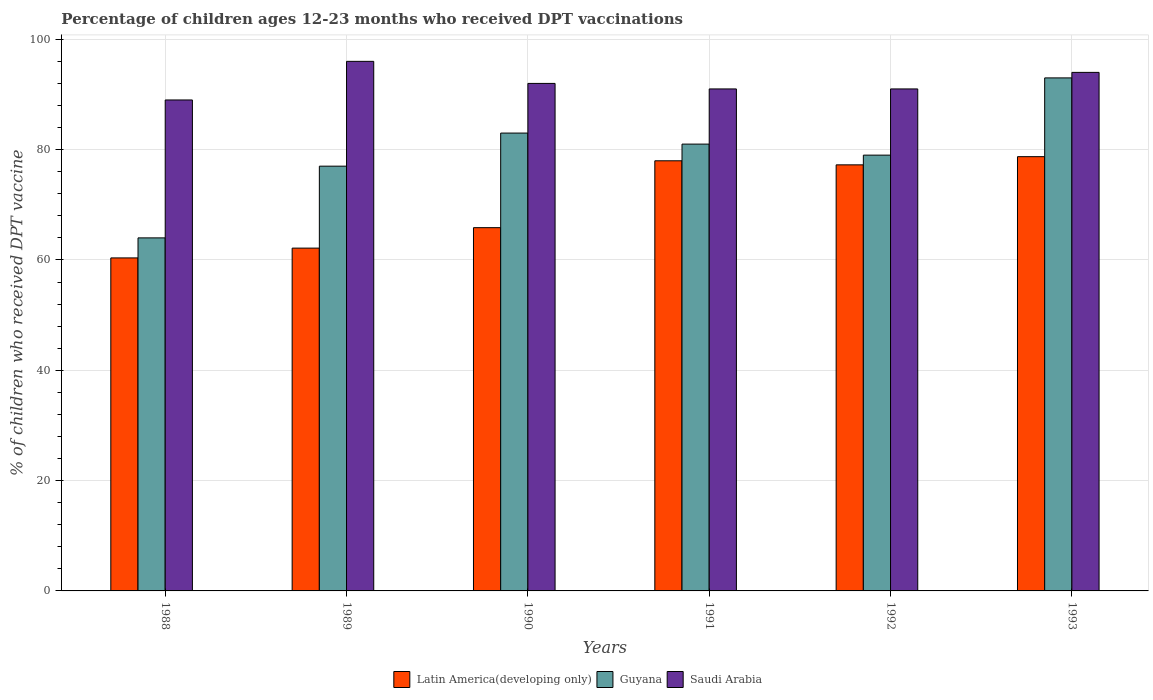How many groups of bars are there?
Keep it short and to the point. 6. Are the number of bars per tick equal to the number of legend labels?
Your answer should be very brief. Yes. What is the percentage of children who received DPT vaccination in Guyana in 1992?
Make the answer very short. 79. Across all years, what is the maximum percentage of children who received DPT vaccination in Guyana?
Your response must be concise. 93. Across all years, what is the minimum percentage of children who received DPT vaccination in Guyana?
Provide a short and direct response. 64. In which year was the percentage of children who received DPT vaccination in Saudi Arabia maximum?
Keep it short and to the point. 1989. What is the total percentage of children who received DPT vaccination in Guyana in the graph?
Make the answer very short. 477. What is the difference between the percentage of children who received DPT vaccination in Guyana in 1990 and that in 1991?
Give a very brief answer. 2. What is the difference between the percentage of children who received DPT vaccination in Guyana in 1993 and the percentage of children who received DPT vaccination in Saudi Arabia in 1989?
Ensure brevity in your answer.  -3. What is the average percentage of children who received DPT vaccination in Latin America(developing only) per year?
Provide a short and direct response. 70.38. In the year 1991, what is the difference between the percentage of children who received DPT vaccination in Guyana and percentage of children who received DPT vaccination in Saudi Arabia?
Offer a very short reply. -10. What is the ratio of the percentage of children who received DPT vaccination in Saudi Arabia in 1990 to that in 1991?
Your answer should be compact. 1.01. Is the percentage of children who received DPT vaccination in Latin America(developing only) in 1988 less than that in 1993?
Keep it short and to the point. Yes. What is the difference between the highest and the second highest percentage of children who received DPT vaccination in Latin America(developing only)?
Your response must be concise. 0.75. What is the difference between the highest and the lowest percentage of children who received DPT vaccination in Latin America(developing only)?
Offer a very short reply. 18.35. In how many years, is the percentage of children who received DPT vaccination in Saudi Arabia greater than the average percentage of children who received DPT vaccination in Saudi Arabia taken over all years?
Offer a very short reply. 2. Is the sum of the percentage of children who received DPT vaccination in Latin America(developing only) in 1991 and 1992 greater than the maximum percentage of children who received DPT vaccination in Guyana across all years?
Offer a very short reply. Yes. What does the 1st bar from the left in 1991 represents?
Your response must be concise. Latin America(developing only). What does the 1st bar from the right in 1992 represents?
Give a very brief answer. Saudi Arabia. Is it the case that in every year, the sum of the percentage of children who received DPT vaccination in Latin America(developing only) and percentage of children who received DPT vaccination in Saudi Arabia is greater than the percentage of children who received DPT vaccination in Guyana?
Your answer should be compact. Yes. How many bars are there?
Provide a short and direct response. 18. Where does the legend appear in the graph?
Ensure brevity in your answer.  Bottom center. What is the title of the graph?
Your response must be concise. Percentage of children ages 12-23 months who received DPT vaccinations. Does "Curacao" appear as one of the legend labels in the graph?
Offer a terse response. No. What is the label or title of the X-axis?
Offer a very short reply. Years. What is the label or title of the Y-axis?
Make the answer very short. % of children who received DPT vaccine. What is the % of children who received DPT vaccine in Latin America(developing only) in 1988?
Your answer should be very brief. 60.37. What is the % of children who received DPT vaccine of Saudi Arabia in 1988?
Provide a succinct answer. 89. What is the % of children who received DPT vaccine of Latin America(developing only) in 1989?
Make the answer very short. 62.14. What is the % of children who received DPT vaccine in Saudi Arabia in 1989?
Make the answer very short. 96. What is the % of children who received DPT vaccine of Latin America(developing only) in 1990?
Your answer should be compact. 65.85. What is the % of children who received DPT vaccine in Saudi Arabia in 1990?
Give a very brief answer. 92. What is the % of children who received DPT vaccine in Latin America(developing only) in 1991?
Offer a terse response. 77.97. What is the % of children who received DPT vaccine of Guyana in 1991?
Make the answer very short. 81. What is the % of children who received DPT vaccine in Saudi Arabia in 1991?
Your answer should be compact. 91. What is the % of children who received DPT vaccine in Latin America(developing only) in 1992?
Your answer should be very brief. 77.24. What is the % of children who received DPT vaccine of Guyana in 1992?
Offer a very short reply. 79. What is the % of children who received DPT vaccine of Saudi Arabia in 1992?
Offer a terse response. 91. What is the % of children who received DPT vaccine of Latin America(developing only) in 1993?
Your answer should be very brief. 78.72. What is the % of children who received DPT vaccine in Guyana in 1993?
Keep it short and to the point. 93. What is the % of children who received DPT vaccine in Saudi Arabia in 1993?
Offer a very short reply. 94. Across all years, what is the maximum % of children who received DPT vaccine of Latin America(developing only)?
Your answer should be very brief. 78.72. Across all years, what is the maximum % of children who received DPT vaccine in Guyana?
Your response must be concise. 93. Across all years, what is the maximum % of children who received DPT vaccine of Saudi Arabia?
Keep it short and to the point. 96. Across all years, what is the minimum % of children who received DPT vaccine of Latin America(developing only)?
Ensure brevity in your answer.  60.37. Across all years, what is the minimum % of children who received DPT vaccine in Saudi Arabia?
Provide a succinct answer. 89. What is the total % of children who received DPT vaccine in Latin America(developing only) in the graph?
Offer a terse response. 422.3. What is the total % of children who received DPT vaccine of Guyana in the graph?
Provide a succinct answer. 477. What is the total % of children who received DPT vaccine in Saudi Arabia in the graph?
Offer a very short reply. 553. What is the difference between the % of children who received DPT vaccine in Latin America(developing only) in 1988 and that in 1989?
Provide a succinct answer. -1.77. What is the difference between the % of children who received DPT vaccine in Guyana in 1988 and that in 1989?
Provide a short and direct response. -13. What is the difference between the % of children who received DPT vaccine in Latin America(developing only) in 1988 and that in 1990?
Your answer should be compact. -5.48. What is the difference between the % of children who received DPT vaccine in Guyana in 1988 and that in 1990?
Your answer should be very brief. -19. What is the difference between the % of children who received DPT vaccine of Latin America(developing only) in 1988 and that in 1991?
Your response must be concise. -17.61. What is the difference between the % of children who received DPT vaccine of Latin America(developing only) in 1988 and that in 1992?
Make the answer very short. -16.87. What is the difference between the % of children who received DPT vaccine of Latin America(developing only) in 1988 and that in 1993?
Your response must be concise. -18.35. What is the difference between the % of children who received DPT vaccine in Guyana in 1988 and that in 1993?
Your answer should be compact. -29. What is the difference between the % of children who received DPT vaccine of Latin America(developing only) in 1989 and that in 1990?
Offer a terse response. -3.71. What is the difference between the % of children who received DPT vaccine of Guyana in 1989 and that in 1990?
Provide a short and direct response. -6. What is the difference between the % of children who received DPT vaccine in Latin America(developing only) in 1989 and that in 1991?
Offer a very short reply. -15.83. What is the difference between the % of children who received DPT vaccine in Latin America(developing only) in 1989 and that in 1992?
Keep it short and to the point. -15.1. What is the difference between the % of children who received DPT vaccine of Guyana in 1989 and that in 1992?
Your answer should be compact. -2. What is the difference between the % of children who received DPT vaccine in Latin America(developing only) in 1989 and that in 1993?
Ensure brevity in your answer.  -16.58. What is the difference between the % of children who received DPT vaccine of Guyana in 1989 and that in 1993?
Keep it short and to the point. -16. What is the difference between the % of children who received DPT vaccine in Saudi Arabia in 1989 and that in 1993?
Provide a short and direct response. 2. What is the difference between the % of children who received DPT vaccine of Latin America(developing only) in 1990 and that in 1991?
Provide a short and direct response. -12.12. What is the difference between the % of children who received DPT vaccine of Latin America(developing only) in 1990 and that in 1992?
Offer a terse response. -11.39. What is the difference between the % of children who received DPT vaccine in Saudi Arabia in 1990 and that in 1992?
Offer a terse response. 1. What is the difference between the % of children who received DPT vaccine in Latin America(developing only) in 1990 and that in 1993?
Provide a short and direct response. -12.87. What is the difference between the % of children who received DPT vaccine of Saudi Arabia in 1990 and that in 1993?
Ensure brevity in your answer.  -2. What is the difference between the % of children who received DPT vaccine of Latin America(developing only) in 1991 and that in 1992?
Offer a very short reply. 0.73. What is the difference between the % of children who received DPT vaccine of Guyana in 1991 and that in 1992?
Give a very brief answer. 2. What is the difference between the % of children who received DPT vaccine of Latin America(developing only) in 1991 and that in 1993?
Your answer should be compact. -0.75. What is the difference between the % of children who received DPT vaccine of Latin America(developing only) in 1992 and that in 1993?
Keep it short and to the point. -1.48. What is the difference between the % of children who received DPT vaccine of Guyana in 1992 and that in 1993?
Make the answer very short. -14. What is the difference between the % of children who received DPT vaccine of Latin America(developing only) in 1988 and the % of children who received DPT vaccine of Guyana in 1989?
Make the answer very short. -16.63. What is the difference between the % of children who received DPT vaccine in Latin America(developing only) in 1988 and the % of children who received DPT vaccine in Saudi Arabia in 1989?
Make the answer very short. -35.63. What is the difference between the % of children who received DPT vaccine of Guyana in 1988 and the % of children who received DPT vaccine of Saudi Arabia in 1989?
Give a very brief answer. -32. What is the difference between the % of children who received DPT vaccine of Latin America(developing only) in 1988 and the % of children who received DPT vaccine of Guyana in 1990?
Provide a succinct answer. -22.63. What is the difference between the % of children who received DPT vaccine of Latin America(developing only) in 1988 and the % of children who received DPT vaccine of Saudi Arabia in 1990?
Keep it short and to the point. -31.63. What is the difference between the % of children who received DPT vaccine in Guyana in 1988 and the % of children who received DPT vaccine in Saudi Arabia in 1990?
Your answer should be very brief. -28. What is the difference between the % of children who received DPT vaccine in Latin America(developing only) in 1988 and the % of children who received DPT vaccine in Guyana in 1991?
Offer a very short reply. -20.63. What is the difference between the % of children who received DPT vaccine of Latin America(developing only) in 1988 and the % of children who received DPT vaccine of Saudi Arabia in 1991?
Offer a very short reply. -30.63. What is the difference between the % of children who received DPT vaccine of Guyana in 1988 and the % of children who received DPT vaccine of Saudi Arabia in 1991?
Offer a very short reply. -27. What is the difference between the % of children who received DPT vaccine of Latin America(developing only) in 1988 and the % of children who received DPT vaccine of Guyana in 1992?
Provide a short and direct response. -18.63. What is the difference between the % of children who received DPT vaccine in Latin America(developing only) in 1988 and the % of children who received DPT vaccine in Saudi Arabia in 1992?
Your answer should be very brief. -30.63. What is the difference between the % of children who received DPT vaccine of Guyana in 1988 and the % of children who received DPT vaccine of Saudi Arabia in 1992?
Make the answer very short. -27. What is the difference between the % of children who received DPT vaccine of Latin America(developing only) in 1988 and the % of children who received DPT vaccine of Guyana in 1993?
Your answer should be compact. -32.63. What is the difference between the % of children who received DPT vaccine of Latin America(developing only) in 1988 and the % of children who received DPT vaccine of Saudi Arabia in 1993?
Ensure brevity in your answer.  -33.63. What is the difference between the % of children who received DPT vaccine of Guyana in 1988 and the % of children who received DPT vaccine of Saudi Arabia in 1993?
Keep it short and to the point. -30. What is the difference between the % of children who received DPT vaccine in Latin America(developing only) in 1989 and the % of children who received DPT vaccine in Guyana in 1990?
Offer a very short reply. -20.86. What is the difference between the % of children who received DPT vaccine in Latin America(developing only) in 1989 and the % of children who received DPT vaccine in Saudi Arabia in 1990?
Give a very brief answer. -29.86. What is the difference between the % of children who received DPT vaccine of Guyana in 1989 and the % of children who received DPT vaccine of Saudi Arabia in 1990?
Your answer should be compact. -15. What is the difference between the % of children who received DPT vaccine in Latin America(developing only) in 1989 and the % of children who received DPT vaccine in Guyana in 1991?
Keep it short and to the point. -18.86. What is the difference between the % of children who received DPT vaccine of Latin America(developing only) in 1989 and the % of children who received DPT vaccine of Saudi Arabia in 1991?
Make the answer very short. -28.86. What is the difference between the % of children who received DPT vaccine in Guyana in 1989 and the % of children who received DPT vaccine in Saudi Arabia in 1991?
Keep it short and to the point. -14. What is the difference between the % of children who received DPT vaccine of Latin America(developing only) in 1989 and the % of children who received DPT vaccine of Guyana in 1992?
Offer a very short reply. -16.86. What is the difference between the % of children who received DPT vaccine in Latin America(developing only) in 1989 and the % of children who received DPT vaccine in Saudi Arabia in 1992?
Make the answer very short. -28.86. What is the difference between the % of children who received DPT vaccine of Guyana in 1989 and the % of children who received DPT vaccine of Saudi Arabia in 1992?
Provide a succinct answer. -14. What is the difference between the % of children who received DPT vaccine in Latin America(developing only) in 1989 and the % of children who received DPT vaccine in Guyana in 1993?
Provide a succinct answer. -30.86. What is the difference between the % of children who received DPT vaccine in Latin America(developing only) in 1989 and the % of children who received DPT vaccine in Saudi Arabia in 1993?
Provide a short and direct response. -31.86. What is the difference between the % of children who received DPT vaccine of Guyana in 1989 and the % of children who received DPT vaccine of Saudi Arabia in 1993?
Provide a succinct answer. -17. What is the difference between the % of children who received DPT vaccine in Latin America(developing only) in 1990 and the % of children who received DPT vaccine in Guyana in 1991?
Your answer should be very brief. -15.15. What is the difference between the % of children who received DPT vaccine of Latin America(developing only) in 1990 and the % of children who received DPT vaccine of Saudi Arabia in 1991?
Your answer should be compact. -25.15. What is the difference between the % of children who received DPT vaccine of Latin America(developing only) in 1990 and the % of children who received DPT vaccine of Guyana in 1992?
Give a very brief answer. -13.15. What is the difference between the % of children who received DPT vaccine of Latin America(developing only) in 1990 and the % of children who received DPT vaccine of Saudi Arabia in 1992?
Your answer should be compact. -25.15. What is the difference between the % of children who received DPT vaccine of Latin America(developing only) in 1990 and the % of children who received DPT vaccine of Guyana in 1993?
Provide a succinct answer. -27.15. What is the difference between the % of children who received DPT vaccine in Latin America(developing only) in 1990 and the % of children who received DPT vaccine in Saudi Arabia in 1993?
Your response must be concise. -28.15. What is the difference between the % of children who received DPT vaccine in Latin America(developing only) in 1991 and the % of children who received DPT vaccine in Guyana in 1992?
Offer a very short reply. -1.03. What is the difference between the % of children who received DPT vaccine in Latin America(developing only) in 1991 and the % of children who received DPT vaccine in Saudi Arabia in 1992?
Provide a succinct answer. -13.03. What is the difference between the % of children who received DPT vaccine in Latin America(developing only) in 1991 and the % of children who received DPT vaccine in Guyana in 1993?
Offer a terse response. -15.03. What is the difference between the % of children who received DPT vaccine in Latin America(developing only) in 1991 and the % of children who received DPT vaccine in Saudi Arabia in 1993?
Give a very brief answer. -16.03. What is the difference between the % of children who received DPT vaccine in Guyana in 1991 and the % of children who received DPT vaccine in Saudi Arabia in 1993?
Offer a very short reply. -13. What is the difference between the % of children who received DPT vaccine of Latin America(developing only) in 1992 and the % of children who received DPT vaccine of Guyana in 1993?
Your answer should be compact. -15.76. What is the difference between the % of children who received DPT vaccine of Latin America(developing only) in 1992 and the % of children who received DPT vaccine of Saudi Arabia in 1993?
Ensure brevity in your answer.  -16.76. What is the average % of children who received DPT vaccine of Latin America(developing only) per year?
Keep it short and to the point. 70.38. What is the average % of children who received DPT vaccine in Guyana per year?
Your answer should be very brief. 79.5. What is the average % of children who received DPT vaccine in Saudi Arabia per year?
Your answer should be very brief. 92.17. In the year 1988, what is the difference between the % of children who received DPT vaccine of Latin America(developing only) and % of children who received DPT vaccine of Guyana?
Provide a succinct answer. -3.63. In the year 1988, what is the difference between the % of children who received DPT vaccine in Latin America(developing only) and % of children who received DPT vaccine in Saudi Arabia?
Your answer should be compact. -28.63. In the year 1989, what is the difference between the % of children who received DPT vaccine in Latin America(developing only) and % of children who received DPT vaccine in Guyana?
Your answer should be compact. -14.86. In the year 1989, what is the difference between the % of children who received DPT vaccine in Latin America(developing only) and % of children who received DPT vaccine in Saudi Arabia?
Offer a terse response. -33.86. In the year 1989, what is the difference between the % of children who received DPT vaccine of Guyana and % of children who received DPT vaccine of Saudi Arabia?
Your answer should be very brief. -19. In the year 1990, what is the difference between the % of children who received DPT vaccine in Latin America(developing only) and % of children who received DPT vaccine in Guyana?
Your answer should be compact. -17.15. In the year 1990, what is the difference between the % of children who received DPT vaccine of Latin America(developing only) and % of children who received DPT vaccine of Saudi Arabia?
Provide a short and direct response. -26.15. In the year 1991, what is the difference between the % of children who received DPT vaccine of Latin America(developing only) and % of children who received DPT vaccine of Guyana?
Your answer should be very brief. -3.03. In the year 1991, what is the difference between the % of children who received DPT vaccine in Latin America(developing only) and % of children who received DPT vaccine in Saudi Arabia?
Provide a succinct answer. -13.03. In the year 1991, what is the difference between the % of children who received DPT vaccine of Guyana and % of children who received DPT vaccine of Saudi Arabia?
Provide a short and direct response. -10. In the year 1992, what is the difference between the % of children who received DPT vaccine of Latin America(developing only) and % of children who received DPT vaccine of Guyana?
Keep it short and to the point. -1.76. In the year 1992, what is the difference between the % of children who received DPT vaccine of Latin America(developing only) and % of children who received DPT vaccine of Saudi Arabia?
Offer a very short reply. -13.76. In the year 1993, what is the difference between the % of children who received DPT vaccine in Latin America(developing only) and % of children who received DPT vaccine in Guyana?
Your response must be concise. -14.28. In the year 1993, what is the difference between the % of children who received DPT vaccine of Latin America(developing only) and % of children who received DPT vaccine of Saudi Arabia?
Offer a terse response. -15.28. In the year 1993, what is the difference between the % of children who received DPT vaccine in Guyana and % of children who received DPT vaccine in Saudi Arabia?
Provide a short and direct response. -1. What is the ratio of the % of children who received DPT vaccine of Latin America(developing only) in 1988 to that in 1989?
Your response must be concise. 0.97. What is the ratio of the % of children who received DPT vaccine of Guyana in 1988 to that in 1989?
Your answer should be compact. 0.83. What is the ratio of the % of children who received DPT vaccine of Saudi Arabia in 1988 to that in 1989?
Your answer should be compact. 0.93. What is the ratio of the % of children who received DPT vaccine in Latin America(developing only) in 1988 to that in 1990?
Your response must be concise. 0.92. What is the ratio of the % of children who received DPT vaccine in Guyana in 1988 to that in 1990?
Your response must be concise. 0.77. What is the ratio of the % of children who received DPT vaccine of Saudi Arabia in 1988 to that in 1990?
Offer a very short reply. 0.97. What is the ratio of the % of children who received DPT vaccine of Latin America(developing only) in 1988 to that in 1991?
Give a very brief answer. 0.77. What is the ratio of the % of children who received DPT vaccine of Guyana in 1988 to that in 1991?
Your answer should be compact. 0.79. What is the ratio of the % of children who received DPT vaccine of Latin America(developing only) in 1988 to that in 1992?
Your response must be concise. 0.78. What is the ratio of the % of children who received DPT vaccine of Guyana in 1988 to that in 1992?
Give a very brief answer. 0.81. What is the ratio of the % of children who received DPT vaccine of Latin America(developing only) in 1988 to that in 1993?
Offer a terse response. 0.77. What is the ratio of the % of children who received DPT vaccine in Guyana in 1988 to that in 1993?
Keep it short and to the point. 0.69. What is the ratio of the % of children who received DPT vaccine of Saudi Arabia in 1988 to that in 1993?
Provide a short and direct response. 0.95. What is the ratio of the % of children who received DPT vaccine of Latin America(developing only) in 1989 to that in 1990?
Provide a succinct answer. 0.94. What is the ratio of the % of children who received DPT vaccine of Guyana in 1989 to that in 1990?
Provide a succinct answer. 0.93. What is the ratio of the % of children who received DPT vaccine of Saudi Arabia in 1989 to that in 1990?
Your response must be concise. 1.04. What is the ratio of the % of children who received DPT vaccine of Latin America(developing only) in 1989 to that in 1991?
Your response must be concise. 0.8. What is the ratio of the % of children who received DPT vaccine in Guyana in 1989 to that in 1991?
Offer a terse response. 0.95. What is the ratio of the % of children who received DPT vaccine in Saudi Arabia in 1989 to that in 1991?
Your answer should be very brief. 1.05. What is the ratio of the % of children who received DPT vaccine in Latin America(developing only) in 1989 to that in 1992?
Provide a short and direct response. 0.8. What is the ratio of the % of children who received DPT vaccine in Guyana in 1989 to that in 1992?
Your response must be concise. 0.97. What is the ratio of the % of children who received DPT vaccine in Saudi Arabia in 1989 to that in 1992?
Provide a short and direct response. 1.05. What is the ratio of the % of children who received DPT vaccine in Latin America(developing only) in 1989 to that in 1993?
Your answer should be very brief. 0.79. What is the ratio of the % of children who received DPT vaccine in Guyana in 1989 to that in 1993?
Provide a succinct answer. 0.83. What is the ratio of the % of children who received DPT vaccine of Saudi Arabia in 1989 to that in 1993?
Keep it short and to the point. 1.02. What is the ratio of the % of children who received DPT vaccine in Latin America(developing only) in 1990 to that in 1991?
Offer a terse response. 0.84. What is the ratio of the % of children who received DPT vaccine in Guyana in 1990 to that in 1991?
Your answer should be very brief. 1.02. What is the ratio of the % of children who received DPT vaccine of Saudi Arabia in 1990 to that in 1991?
Offer a very short reply. 1.01. What is the ratio of the % of children who received DPT vaccine in Latin America(developing only) in 1990 to that in 1992?
Provide a succinct answer. 0.85. What is the ratio of the % of children who received DPT vaccine in Guyana in 1990 to that in 1992?
Your answer should be very brief. 1.05. What is the ratio of the % of children who received DPT vaccine in Saudi Arabia in 1990 to that in 1992?
Make the answer very short. 1.01. What is the ratio of the % of children who received DPT vaccine of Latin America(developing only) in 1990 to that in 1993?
Your response must be concise. 0.84. What is the ratio of the % of children who received DPT vaccine in Guyana in 1990 to that in 1993?
Make the answer very short. 0.89. What is the ratio of the % of children who received DPT vaccine of Saudi Arabia in 1990 to that in 1993?
Offer a very short reply. 0.98. What is the ratio of the % of children who received DPT vaccine of Latin America(developing only) in 1991 to that in 1992?
Ensure brevity in your answer.  1.01. What is the ratio of the % of children who received DPT vaccine of Guyana in 1991 to that in 1992?
Keep it short and to the point. 1.03. What is the ratio of the % of children who received DPT vaccine of Guyana in 1991 to that in 1993?
Your response must be concise. 0.87. What is the ratio of the % of children who received DPT vaccine in Saudi Arabia in 1991 to that in 1993?
Offer a very short reply. 0.97. What is the ratio of the % of children who received DPT vaccine of Latin America(developing only) in 1992 to that in 1993?
Your response must be concise. 0.98. What is the ratio of the % of children who received DPT vaccine in Guyana in 1992 to that in 1993?
Offer a terse response. 0.85. What is the ratio of the % of children who received DPT vaccine of Saudi Arabia in 1992 to that in 1993?
Ensure brevity in your answer.  0.97. What is the difference between the highest and the second highest % of children who received DPT vaccine in Latin America(developing only)?
Provide a short and direct response. 0.75. What is the difference between the highest and the second highest % of children who received DPT vaccine in Guyana?
Provide a short and direct response. 10. What is the difference between the highest and the lowest % of children who received DPT vaccine of Latin America(developing only)?
Your answer should be very brief. 18.35. 